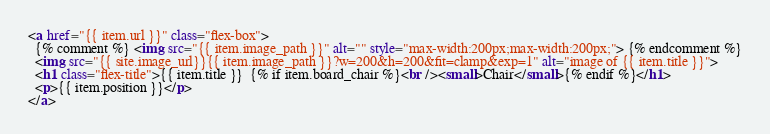Convert code to text. <code><loc_0><loc_0><loc_500><loc_500><_HTML_><a href="{{ item.url }}" class="flex-box">
  {% comment %} <img src="{{ item.image_path }}" alt="" style="max-width:200px;max-width:200px;"> {% endcomment %}
  <img src="{{ site.image_url}}{{ item.image_path }}?w=200&h=200&fit=clamp&exp=1" alt="image of {{ item.title }}">
  <h1 class="flex-title">{{ item.title }}  {% if item.board_chair %}<br /><small>Chair</small>{% endif %}</h1>
  <p>{{ item.position }}</p>
</a>
</code> 